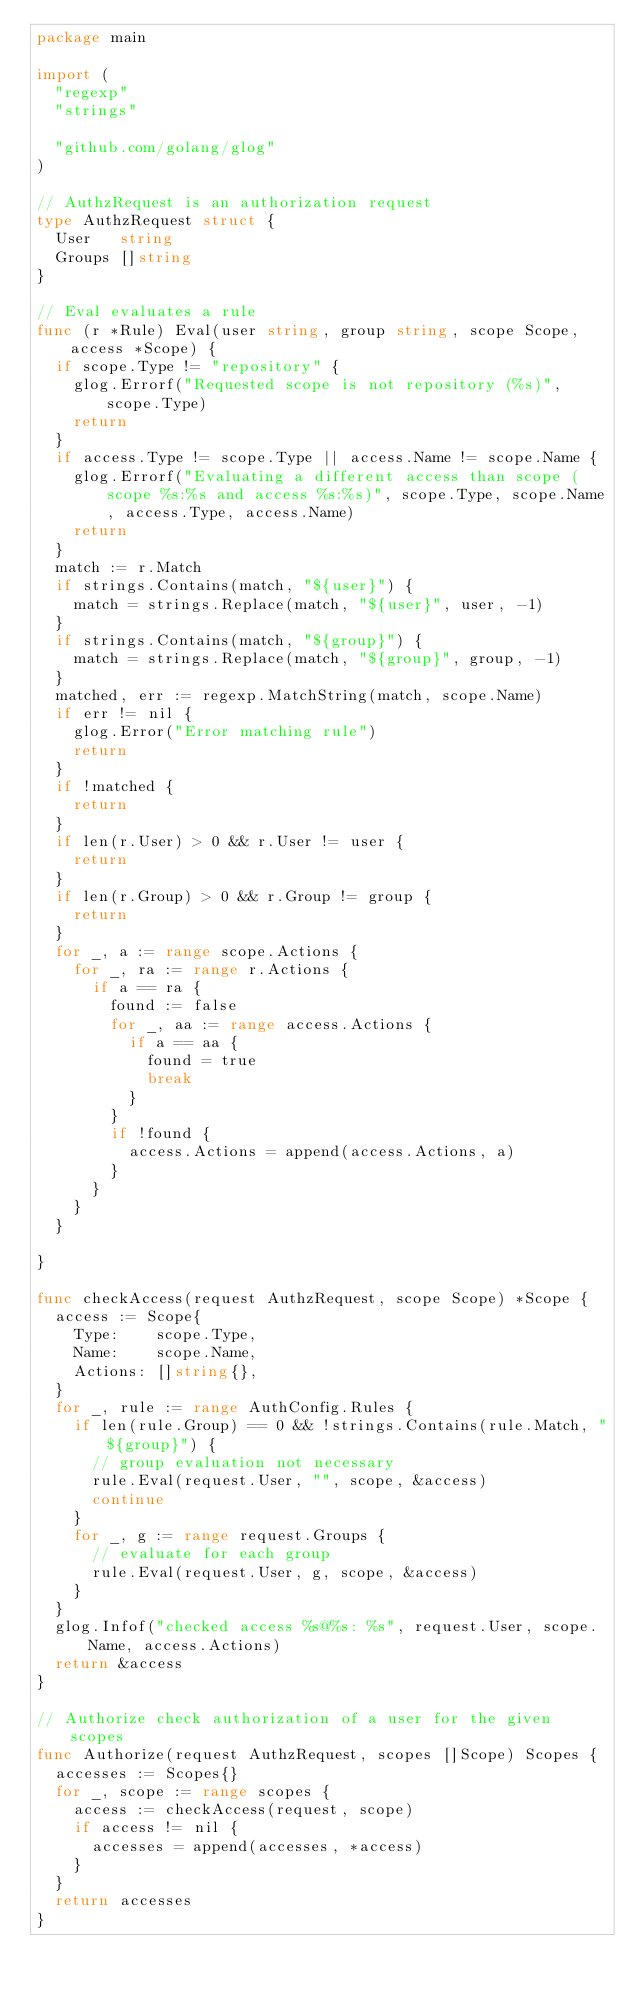Convert code to text. <code><loc_0><loc_0><loc_500><loc_500><_Go_>package main

import (
	"regexp"
	"strings"

	"github.com/golang/glog"
)

// AuthzRequest is an authorization request
type AuthzRequest struct {
	User   string
	Groups []string
}

// Eval evaluates a rule
func (r *Rule) Eval(user string, group string, scope Scope, access *Scope) {
	if scope.Type != "repository" {
		glog.Errorf("Requested scope is not repository (%s)", scope.Type)
		return
	}
	if access.Type != scope.Type || access.Name != scope.Name {
		glog.Errorf("Evaluating a different access than scope (scope %s:%s and access %s:%s)", scope.Type, scope.Name, access.Type, access.Name)
		return
	}
	match := r.Match
	if strings.Contains(match, "${user}") {
		match = strings.Replace(match, "${user}", user, -1)
	}
	if strings.Contains(match, "${group}") {
		match = strings.Replace(match, "${group}", group, -1)
	}
	matched, err := regexp.MatchString(match, scope.Name)
	if err != nil {
		glog.Error("Error matching rule")
		return
	}
	if !matched {
		return
	}
	if len(r.User) > 0 && r.User != user {
		return
	}
	if len(r.Group) > 0 && r.Group != group {
		return
	}
	for _, a := range scope.Actions {
		for _, ra := range r.Actions {
			if a == ra {
				found := false
				for _, aa := range access.Actions {
					if a == aa {
						found = true
						break
					}
				}
				if !found {
					access.Actions = append(access.Actions, a)
				}
			}
		}
	}

}

func checkAccess(request AuthzRequest, scope Scope) *Scope {
	access := Scope{
		Type:    scope.Type,
		Name:    scope.Name,
		Actions: []string{},
	}
	for _, rule := range AuthConfig.Rules {
		if len(rule.Group) == 0 && !strings.Contains(rule.Match, "${group}") {
			// group evaluation not necessary
			rule.Eval(request.User, "", scope, &access)
			continue
		}
		for _, g := range request.Groups {
			// evaluate for each group
			rule.Eval(request.User, g, scope, &access)
		}
	}
	glog.Infof("checked access %s@%s: %s", request.User, scope.Name, access.Actions)
	return &access
}

// Authorize check authorization of a user for the given scopes
func Authorize(request AuthzRequest, scopes []Scope) Scopes {
	accesses := Scopes{}
	for _, scope := range scopes {
		access := checkAccess(request, scope)
		if access != nil {
			accesses = append(accesses, *access)
		}
	}
	return accesses
}
</code> 